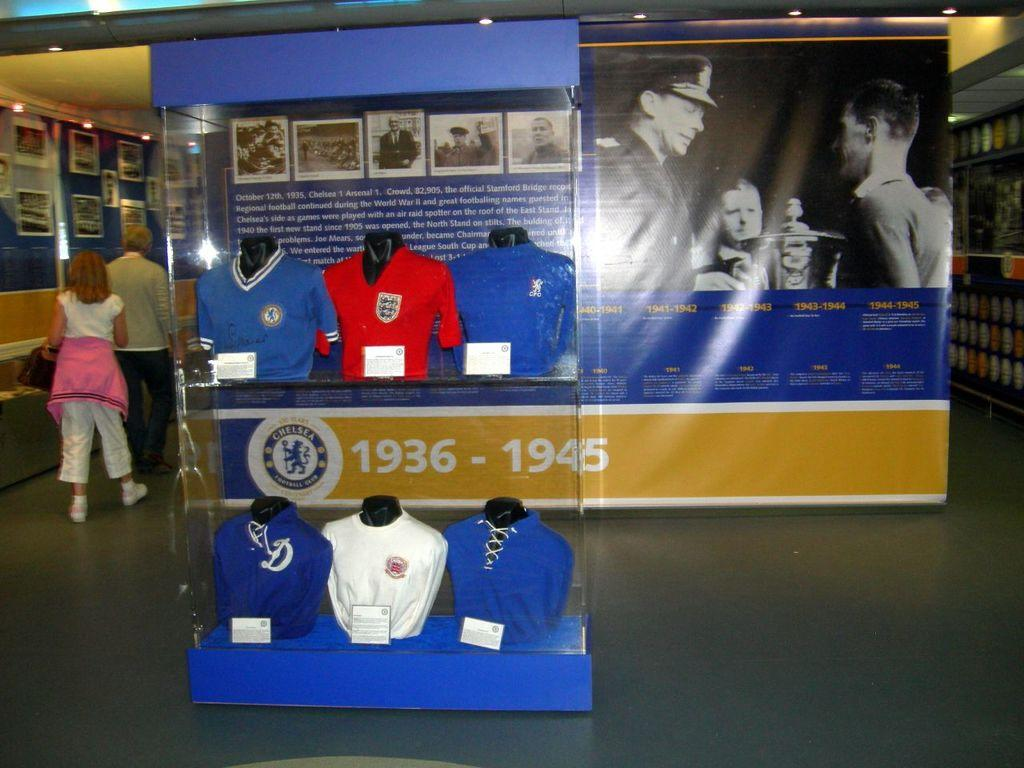<image>
Provide a brief description of the given image. A display in a sports museum showing a timeline including 1936-1945 of football. 